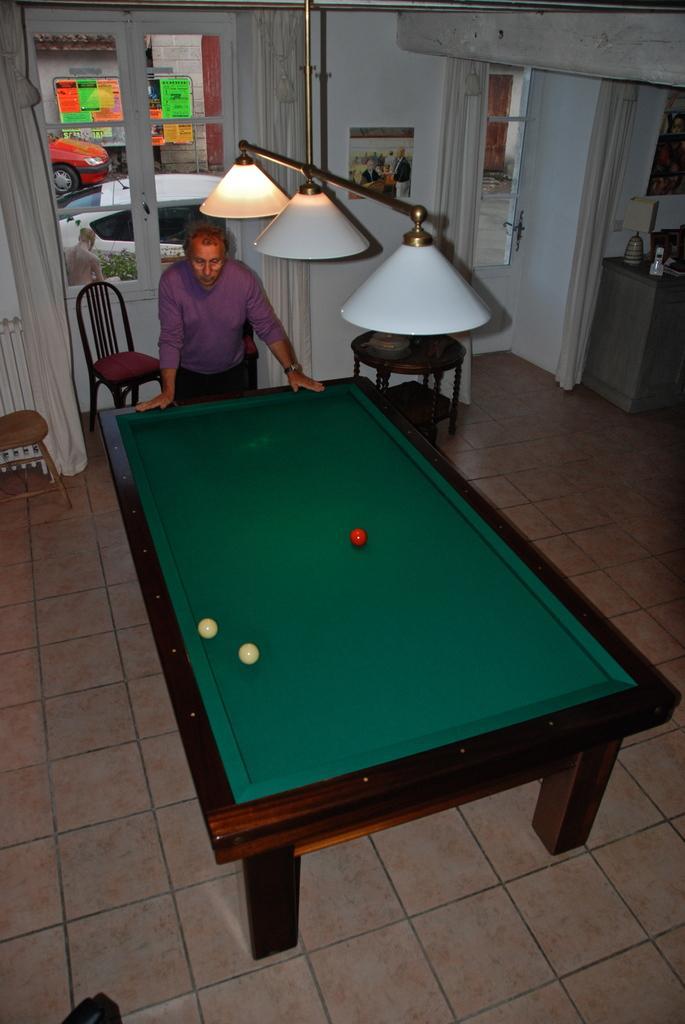Can you describe this image briefly? In this image, a person is standing in front of the table top table. On above that a lamp is hanged to the wall. In the background, a window is visible, through which orange and white color cars visible. The walls are white in color. This image is taken inside a house. 